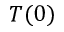Convert formula to latex. <formula><loc_0><loc_0><loc_500><loc_500>T ( 0 )</formula> 